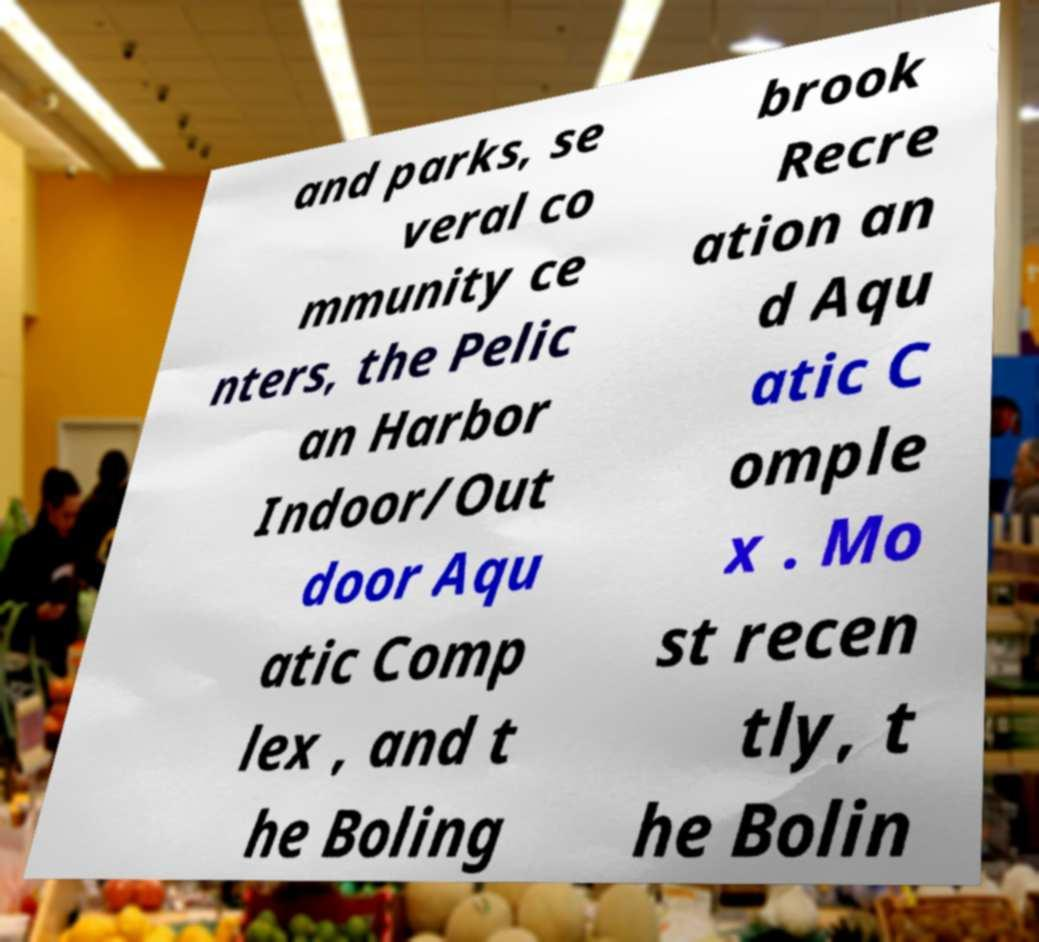Could you extract and type out the text from this image? and parks, se veral co mmunity ce nters, the Pelic an Harbor Indoor/Out door Aqu atic Comp lex , and t he Boling brook Recre ation an d Aqu atic C omple x . Mo st recen tly, t he Bolin 